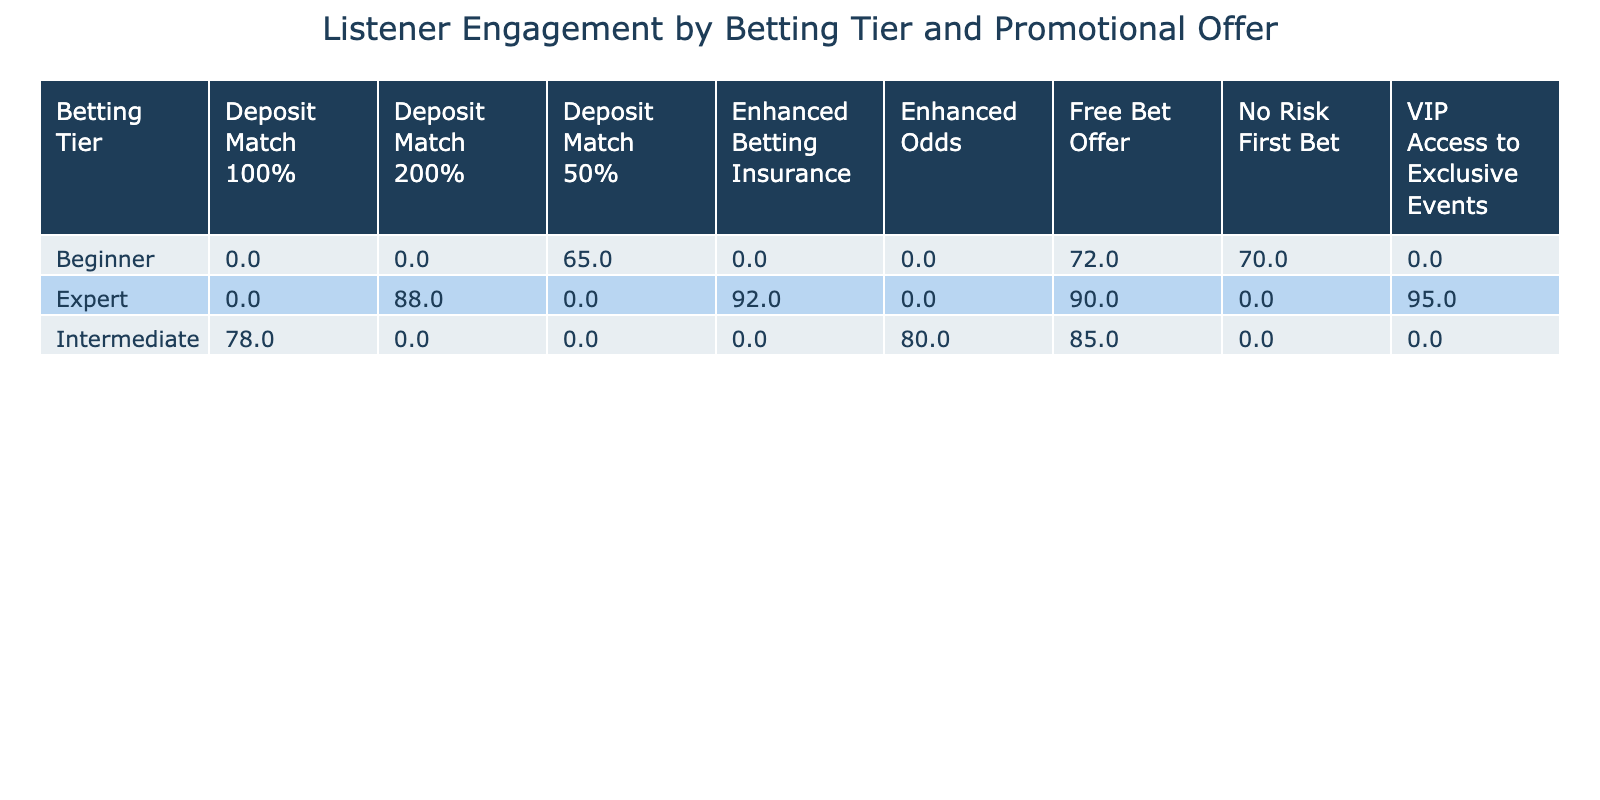What is the Listener Engagement Score for the Beginner tier under the No Risk First Bet promotional offer? The Listener Engagement Score for the Beginner tier under the No Risk First Bet promotional offer is explicitly listed in the table as 70.
Answer: 70 What is the Promotional Offer with the highest Listener Engagement Score for the Expert tier? In the table, the Engagement Scores for the Expert tier are listed as follows: Free Bet Offer (90), Deposit Match 200% (88), VIP Access to Exclusive Events (95), and Enhanced Betting Insurance (92). The highest score among these is 95 for the VIP Access to Exclusive Events.
Answer: VIP Access to Exclusive Events Is the Listener Engagement Score for the Intermediate tier higher under Enhance Odds or Deposit Match 100%? The Listener Engagement Scores for the Intermediate tier are 80 for Enhanced Odds and 78 for Deposit Match 100%. Since 80 is greater than 78, the score is higher under Enhanced Odds.
Answer: Yes What is the average Listener Engagement Score for all promotional offers within the Beginner tier? The Engagement Scores for the Beginner tier are 72 (Free Bet Offer), 65 (Deposit Match 50%), and 70 (No Risk First Bet). To find the average, sum these scores: 72 + 65 + 70 = 207. Then, divide this sum by the number of offers (3): 207 / 3 = 69.
Answer: 69 Which Betting Tier has the lowest summed Listener Engagement Score across all promotional offers? To compare the summed scores, we calculate: Beginner total = 72 + 65 + 70 = 207, Intermediate total = 85 + 78 + 80 = 243, and Expert total = 90 + 88 + 95 + 92 = 365. The lowest total is for the Beginner tier with 207, indicating it has the least engagement.
Answer: Beginner Which promotional offer has the same Listener Engagement Score across all tiers? In examining the Engagement Scores, we see the scores vary across the promotional offers for different tiers. Since none are the same for every tier, this questions confirms that no promotional offer has identical scores across all tiers.
Answer: No What is the difference in Listener Engagement Score between the highest and lowest scoring offers for the Intermediate tier? The Engagement Scores for the Intermediate tier are 85 (Free Bet Offer), 78 (Deposit Match 100%), and 80 (Enhanced Odds). The highest is 85 and the lowest is 78, leading to a difference of 85 - 78 = 7.
Answer: 7 What percentage of the highest scoring offer across all tiers is the Listener Engagement Score for the Deposit Match 200% offer? The highest score overall is 95 for the VIP Access to Exclusive Events. The score for the Deposit Match 200% offer is 88. To find the percentage: (88 / 95) * 100 = approximately 92.63%.
Answer: Approximately 92.63% 